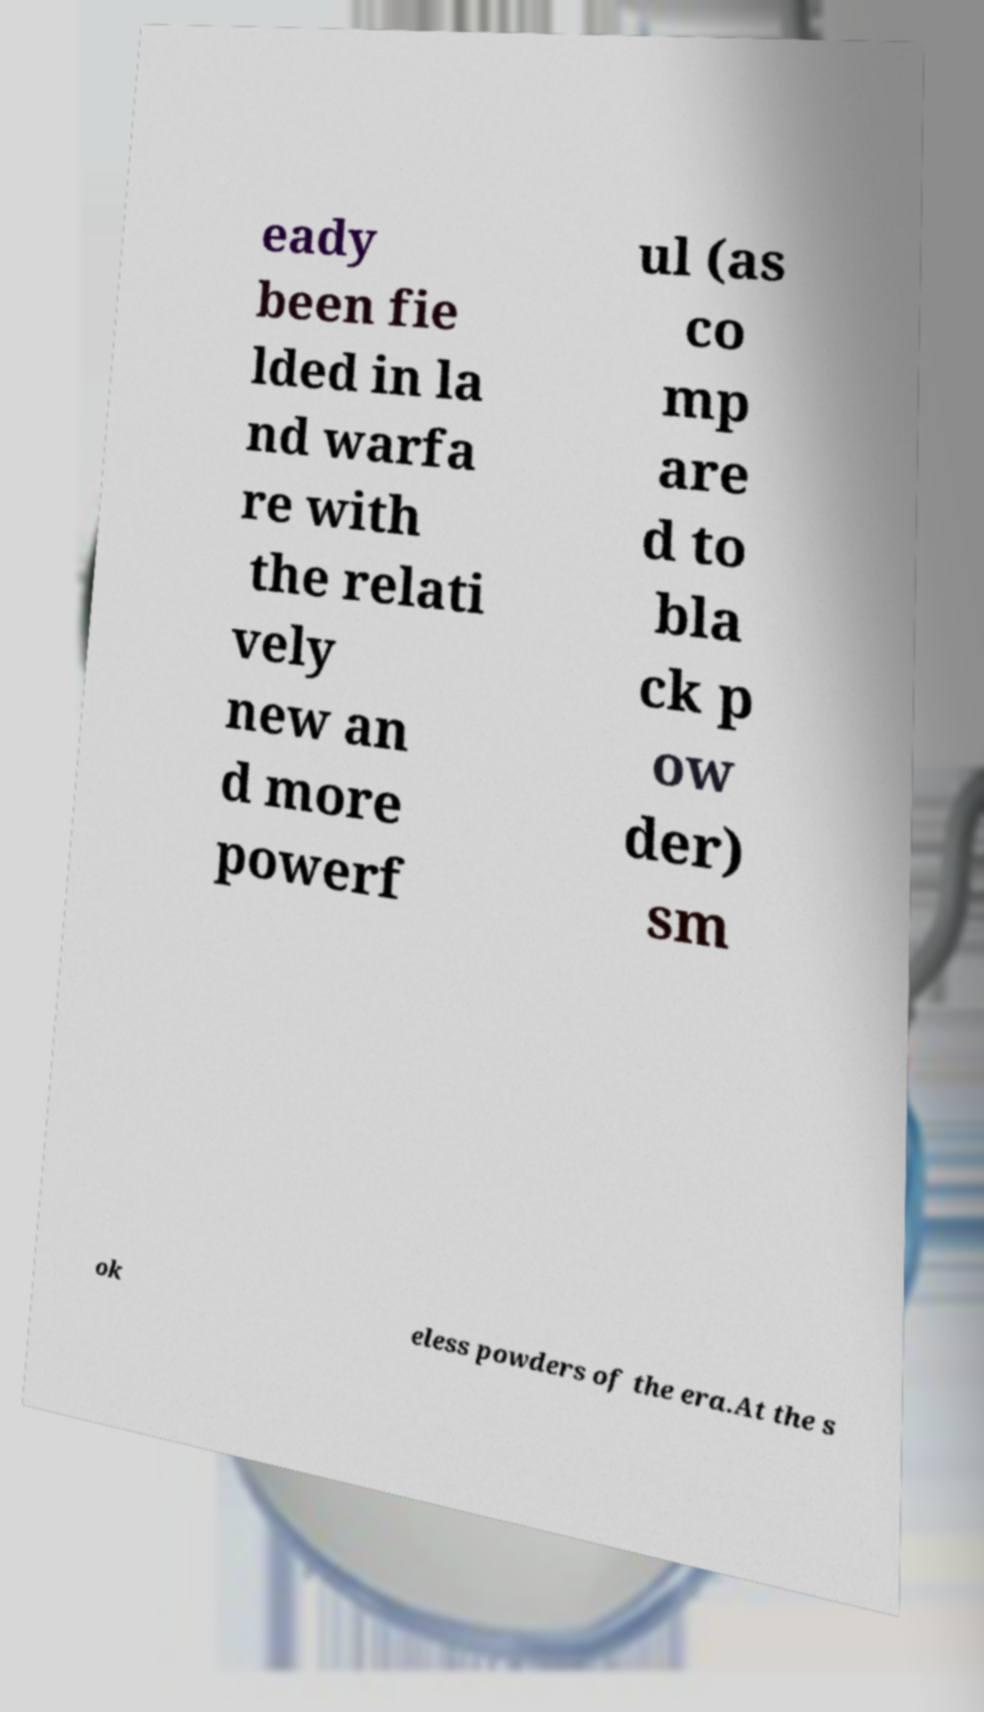I need the written content from this picture converted into text. Can you do that? eady been fie lded in la nd warfa re with the relati vely new an d more powerf ul (as co mp are d to bla ck p ow der) sm ok eless powders of the era.At the s 